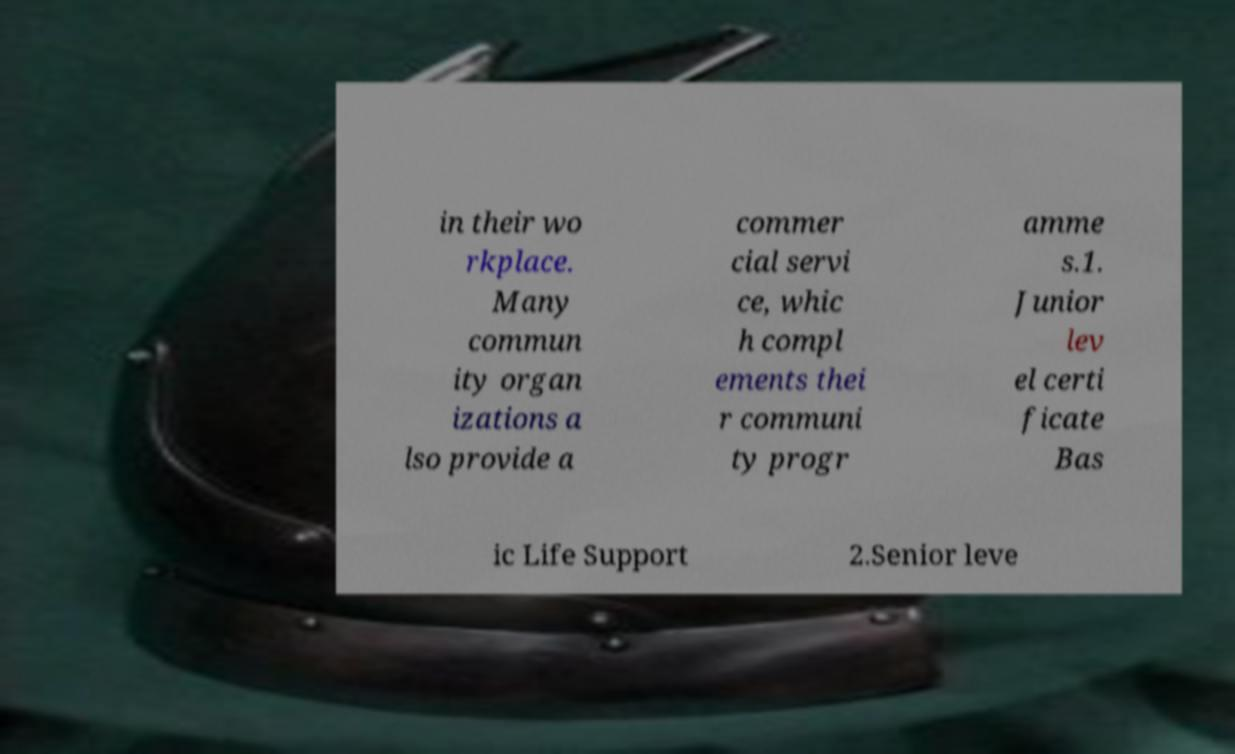For documentation purposes, I need the text within this image transcribed. Could you provide that? in their wo rkplace. Many commun ity organ izations a lso provide a commer cial servi ce, whic h compl ements thei r communi ty progr amme s.1. Junior lev el certi ficate Bas ic Life Support 2.Senior leve 